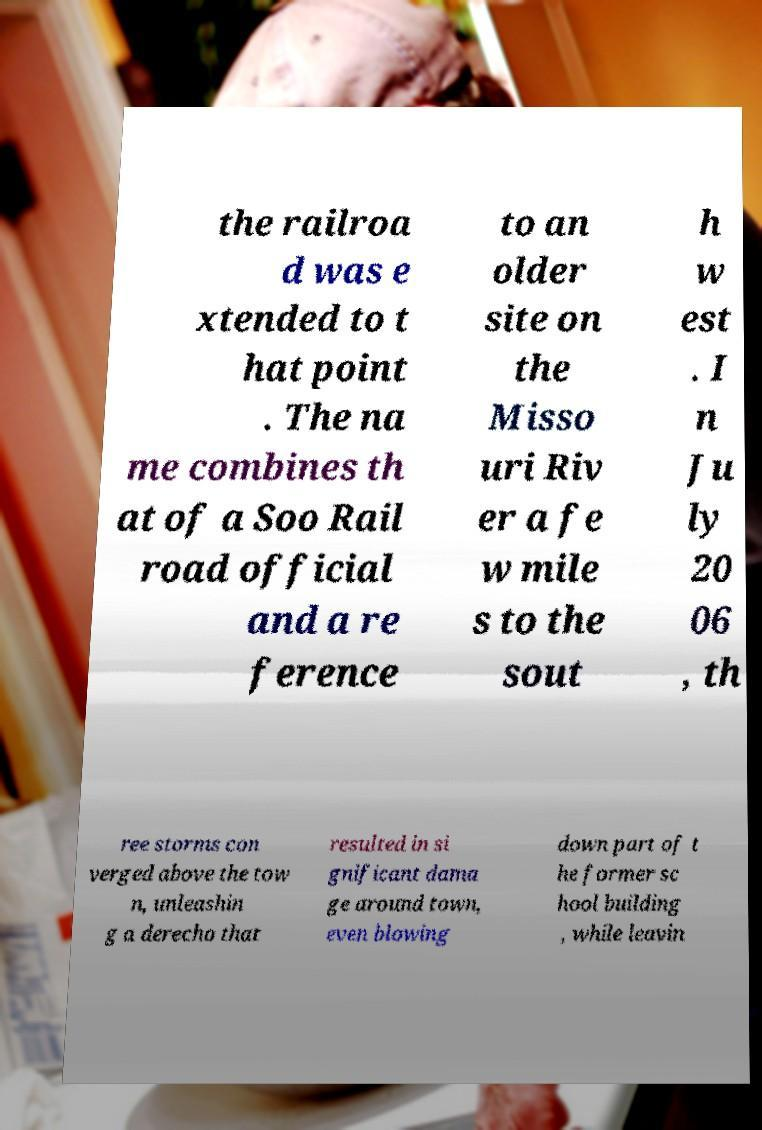There's text embedded in this image that I need extracted. Can you transcribe it verbatim? the railroa d was e xtended to t hat point . The na me combines th at of a Soo Rail road official and a re ference to an older site on the Misso uri Riv er a fe w mile s to the sout h w est . I n Ju ly 20 06 , th ree storms con verged above the tow n, unleashin g a derecho that resulted in si gnificant dama ge around town, even blowing down part of t he former sc hool building , while leavin 